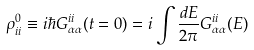Convert formula to latex. <formula><loc_0><loc_0><loc_500><loc_500>\rho ^ { 0 } _ { i i } \equiv i \hbar { G } ^ { i i } _ { \alpha \alpha } ( t = 0 ) = i \int \frac { d E } { 2 \pi } G ^ { i i } _ { \alpha \alpha } ( E )</formula> 